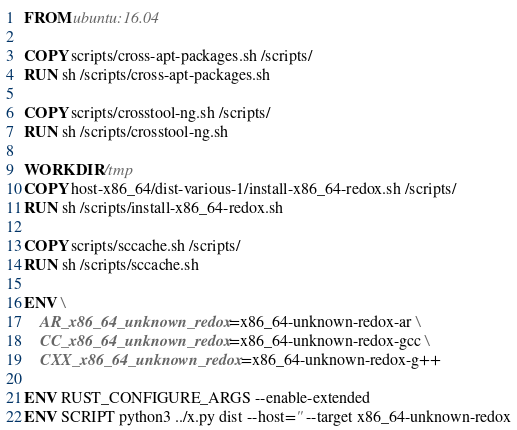Convert code to text. <code><loc_0><loc_0><loc_500><loc_500><_Dockerfile_>FROM ubuntu:16.04

COPY scripts/cross-apt-packages.sh /scripts/
RUN sh /scripts/cross-apt-packages.sh

COPY scripts/crosstool-ng.sh /scripts/
RUN sh /scripts/crosstool-ng.sh

WORKDIR /tmp
COPY host-x86_64/dist-various-1/install-x86_64-redox.sh /scripts/
RUN sh /scripts/install-x86_64-redox.sh

COPY scripts/sccache.sh /scripts/
RUN sh /scripts/sccache.sh

ENV \
    AR_x86_64_unknown_redox=x86_64-unknown-redox-ar \
    CC_x86_64_unknown_redox=x86_64-unknown-redox-gcc \
    CXX_x86_64_unknown_redox=x86_64-unknown-redox-g++

ENV RUST_CONFIGURE_ARGS --enable-extended
ENV SCRIPT python3 ../x.py dist --host='' --target x86_64-unknown-redox
</code> 